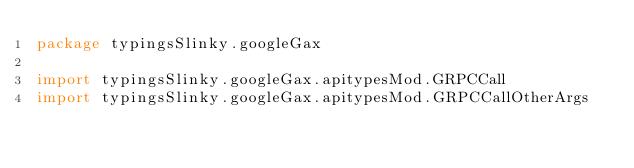<code> <loc_0><loc_0><loc_500><loc_500><_Scala_>package typingsSlinky.googleGax

import typingsSlinky.googleGax.apitypesMod.GRPCCall
import typingsSlinky.googleGax.apitypesMod.GRPCCallOtherArgs</code> 